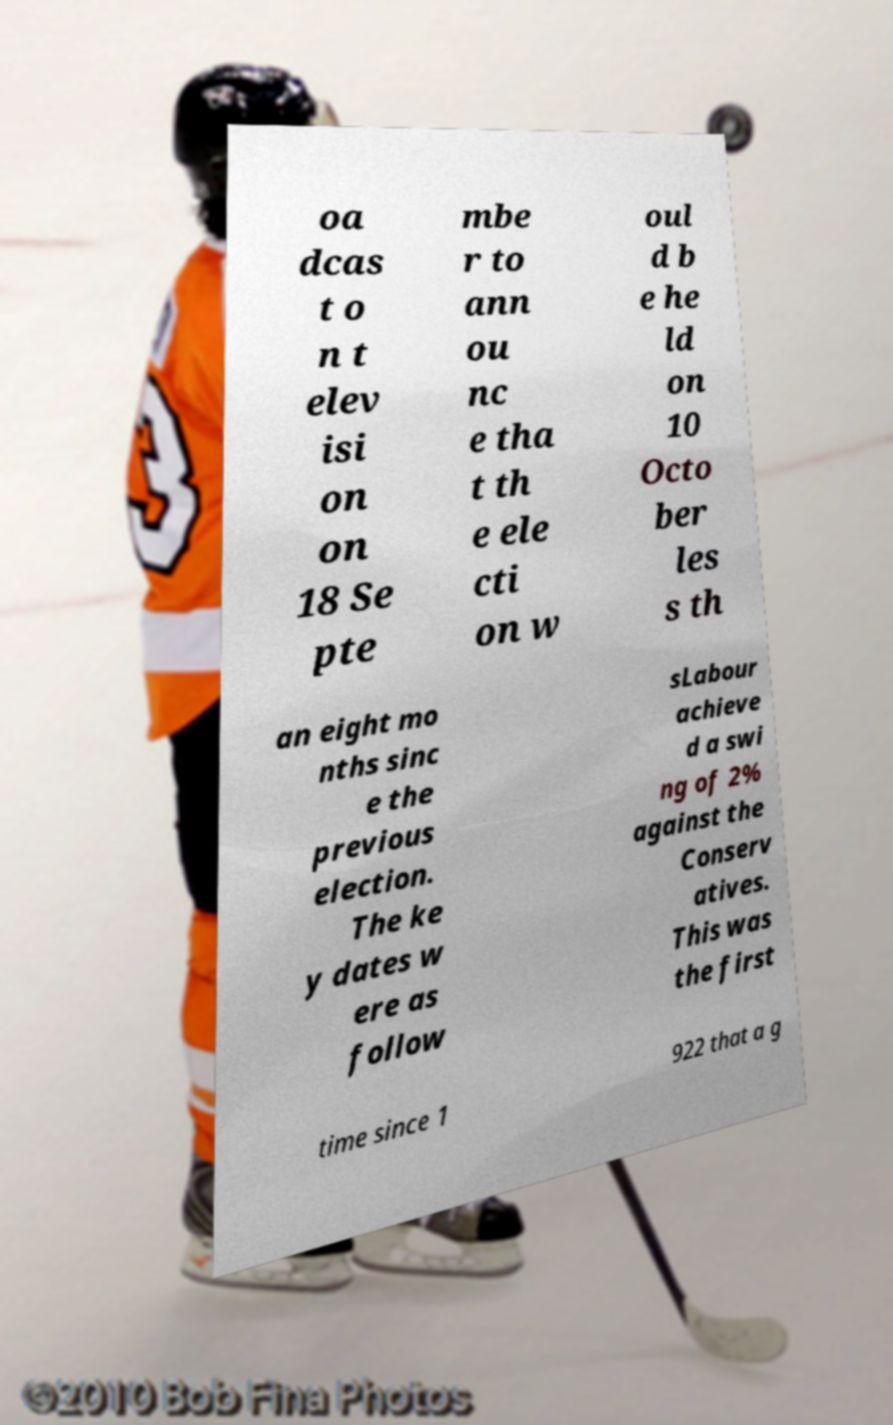Can you read and provide the text displayed in the image?This photo seems to have some interesting text. Can you extract and type it out for me? oa dcas t o n t elev isi on on 18 Se pte mbe r to ann ou nc e tha t th e ele cti on w oul d b e he ld on 10 Octo ber les s th an eight mo nths sinc e the previous election. The ke y dates w ere as follow sLabour achieve d a swi ng of 2% against the Conserv atives. This was the first time since 1 922 that a g 